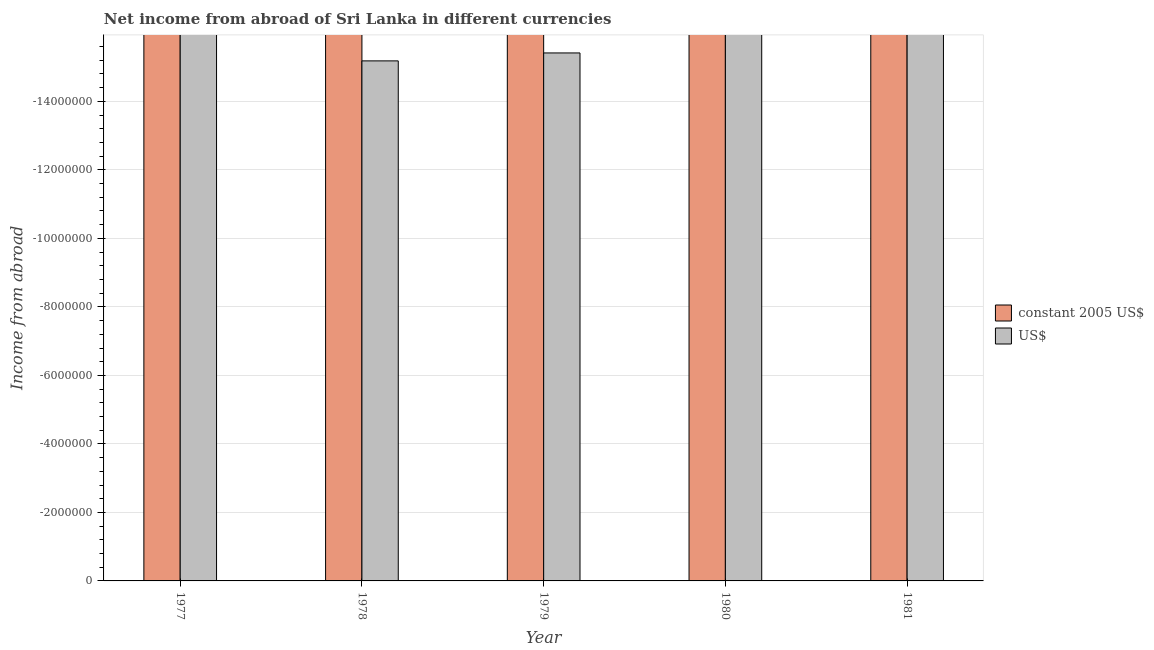How many different coloured bars are there?
Your answer should be very brief. 0. Are the number of bars on each tick of the X-axis equal?
Offer a very short reply. Yes. How many bars are there on the 2nd tick from the left?
Your response must be concise. 0. How many bars are there on the 1st tick from the right?
Your answer should be very brief. 0. What is the label of the 2nd group of bars from the left?
Give a very brief answer. 1978. What is the income from abroad in constant 2005 us$ in 1981?
Provide a short and direct response. 0. What is the total income from abroad in constant 2005 us$ in the graph?
Your response must be concise. 0. What is the difference between the income from abroad in constant 2005 us$ in 1978 and the income from abroad in us$ in 1977?
Provide a short and direct response. 0. In how many years, is the income from abroad in us$ greater than the average income from abroad in us$ taken over all years?
Your answer should be very brief. 0. How many bars are there?
Make the answer very short. 0. Are all the bars in the graph horizontal?
Your response must be concise. No. How many years are there in the graph?
Keep it short and to the point. 5. Does the graph contain any zero values?
Provide a short and direct response. Yes. Does the graph contain grids?
Ensure brevity in your answer.  Yes. Where does the legend appear in the graph?
Give a very brief answer. Center right. How many legend labels are there?
Make the answer very short. 2. What is the title of the graph?
Your answer should be very brief. Net income from abroad of Sri Lanka in different currencies. Does "Travel Items" appear as one of the legend labels in the graph?
Your answer should be compact. No. What is the label or title of the Y-axis?
Give a very brief answer. Income from abroad. What is the Income from abroad in US$ in 1977?
Your response must be concise. 0. What is the Income from abroad in US$ in 1978?
Provide a short and direct response. 0. What is the Income from abroad of constant 2005 US$ in 1979?
Provide a succinct answer. 0. What is the Income from abroad in US$ in 1979?
Provide a short and direct response. 0. What is the Income from abroad in US$ in 1980?
Offer a terse response. 0. What is the total Income from abroad in constant 2005 US$ in the graph?
Ensure brevity in your answer.  0. 